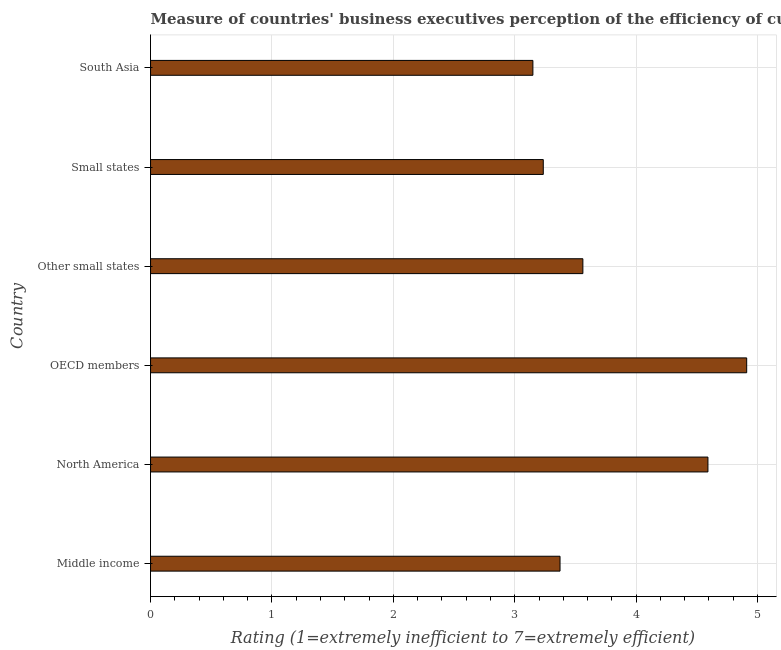What is the title of the graph?
Your answer should be very brief. Measure of countries' business executives perception of the efficiency of customs procedures in 2007. What is the label or title of the X-axis?
Keep it short and to the point. Rating (1=extremely inefficient to 7=extremely efficient). What is the rating measuring burden of customs procedure in Middle income?
Make the answer very short. 3.37. Across all countries, what is the maximum rating measuring burden of customs procedure?
Offer a very short reply. 4.91. Across all countries, what is the minimum rating measuring burden of customs procedure?
Make the answer very short. 3.15. What is the sum of the rating measuring burden of customs procedure?
Your answer should be very brief. 22.82. What is the difference between the rating measuring burden of customs procedure in OECD members and Other small states?
Your answer should be compact. 1.35. What is the average rating measuring burden of customs procedure per country?
Give a very brief answer. 3.8. What is the median rating measuring burden of customs procedure?
Your answer should be compact. 3.47. What is the ratio of the rating measuring burden of customs procedure in Middle income to that in North America?
Your response must be concise. 0.73. Is the difference between the rating measuring burden of customs procedure in OECD members and Other small states greater than the difference between any two countries?
Your answer should be compact. No. What is the difference between the highest and the second highest rating measuring burden of customs procedure?
Your response must be concise. 0.32. What is the difference between the highest and the lowest rating measuring burden of customs procedure?
Provide a short and direct response. 1.76. In how many countries, is the rating measuring burden of customs procedure greater than the average rating measuring burden of customs procedure taken over all countries?
Your answer should be compact. 2. Are all the bars in the graph horizontal?
Offer a terse response. Yes. How many countries are there in the graph?
Offer a terse response. 6. Are the values on the major ticks of X-axis written in scientific E-notation?
Ensure brevity in your answer.  No. What is the Rating (1=extremely inefficient to 7=extremely efficient) in Middle income?
Keep it short and to the point. 3.37. What is the Rating (1=extremely inefficient to 7=extremely efficient) in North America?
Provide a succinct answer. 4.59. What is the Rating (1=extremely inefficient to 7=extremely efficient) of OECD members?
Provide a short and direct response. 4.91. What is the Rating (1=extremely inefficient to 7=extremely efficient) in Other small states?
Provide a short and direct response. 3.56. What is the Rating (1=extremely inefficient to 7=extremely efficient) in Small states?
Your response must be concise. 3.24. What is the Rating (1=extremely inefficient to 7=extremely efficient) of South Asia?
Ensure brevity in your answer.  3.15. What is the difference between the Rating (1=extremely inefficient to 7=extremely efficient) in Middle income and North America?
Your answer should be compact. -1.22. What is the difference between the Rating (1=extremely inefficient to 7=extremely efficient) in Middle income and OECD members?
Give a very brief answer. -1.54. What is the difference between the Rating (1=extremely inefficient to 7=extremely efficient) in Middle income and Other small states?
Make the answer very short. -0.19. What is the difference between the Rating (1=extremely inefficient to 7=extremely efficient) in Middle income and Small states?
Your answer should be compact. 0.14. What is the difference between the Rating (1=extremely inefficient to 7=extremely efficient) in Middle income and South Asia?
Make the answer very short. 0.22. What is the difference between the Rating (1=extremely inefficient to 7=extremely efficient) in North America and OECD members?
Your answer should be very brief. -0.32. What is the difference between the Rating (1=extremely inefficient to 7=extremely efficient) in North America and Other small states?
Give a very brief answer. 1.03. What is the difference between the Rating (1=extremely inefficient to 7=extremely efficient) in North America and Small states?
Provide a succinct answer. 1.36. What is the difference between the Rating (1=extremely inefficient to 7=extremely efficient) in North America and South Asia?
Provide a short and direct response. 1.44. What is the difference between the Rating (1=extremely inefficient to 7=extremely efficient) in OECD members and Other small states?
Your answer should be very brief. 1.35. What is the difference between the Rating (1=extremely inefficient to 7=extremely efficient) in OECD members and Small states?
Keep it short and to the point. 1.68. What is the difference between the Rating (1=extremely inefficient to 7=extremely efficient) in OECD members and South Asia?
Give a very brief answer. 1.76. What is the difference between the Rating (1=extremely inefficient to 7=extremely efficient) in Other small states and Small states?
Keep it short and to the point. 0.33. What is the difference between the Rating (1=extremely inefficient to 7=extremely efficient) in Other small states and South Asia?
Ensure brevity in your answer.  0.41. What is the difference between the Rating (1=extremely inefficient to 7=extremely efficient) in Small states and South Asia?
Your answer should be very brief. 0.09. What is the ratio of the Rating (1=extremely inefficient to 7=extremely efficient) in Middle income to that in North America?
Your answer should be compact. 0.73. What is the ratio of the Rating (1=extremely inefficient to 7=extremely efficient) in Middle income to that in OECD members?
Your answer should be very brief. 0.69. What is the ratio of the Rating (1=extremely inefficient to 7=extremely efficient) in Middle income to that in Other small states?
Provide a short and direct response. 0.95. What is the ratio of the Rating (1=extremely inefficient to 7=extremely efficient) in Middle income to that in Small states?
Your answer should be compact. 1.04. What is the ratio of the Rating (1=extremely inefficient to 7=extremely efficient) in Middle income to that in South Asia?
Your answer should be compact. 1.07. What is the ratio of the Rating (1=extremely inefficient to 7=extremely efficient) in North America to that in OECD members?
Provide a short and direct response. 0.94. What is the ratio of the Rating (1=extremely inefficient to 7=extremely efficient) in North America to that in Other small states?
Ensure brevity in your answer.  1.29. What is the ratio of the Rating (1=extremely inefficient to 7=extremely efficient) in North America to that in Small states?
Make the answer very short. 1.42. What is the ratio of the Rating (1=extremely inefficient to 7=extremely efficient) in North America to that in South Asia?
Give a very brief answer. 1.46. What is the ratio of the Rating (1=extremely inefficient to 7=extremely efficient) in OECD members to that in Other small states?
Offer a terse response. 1.38. What is the ratio of the Rating (1=extremely inefficient to 7=extremely efficient) in OECD members to that in Small states?
Make the answer very short. 1.52. What is the ratio of the Rating (1=extremely inefficient to 7=extremely efficient) in OECD members to that in South Asia?
Ensure brevity in your answer.  1.56. What is the ratio of the Rating (1=extremely inefficient to 7=extremely efficient) in Other small states to that in Small states?
Ensure brevity in your answer.  1.1. What is the ratio of the Rating (1=extremely inefficient to 7=extremely efficient) in Other small states to that in South Asia?
Provide a short and direct response. 1.13. What is the ratio of the Rating (1=extremely inefficient to 7=extremely efficient) in Small states to that in South Asia?
Your answer should be compact. 1.03. 